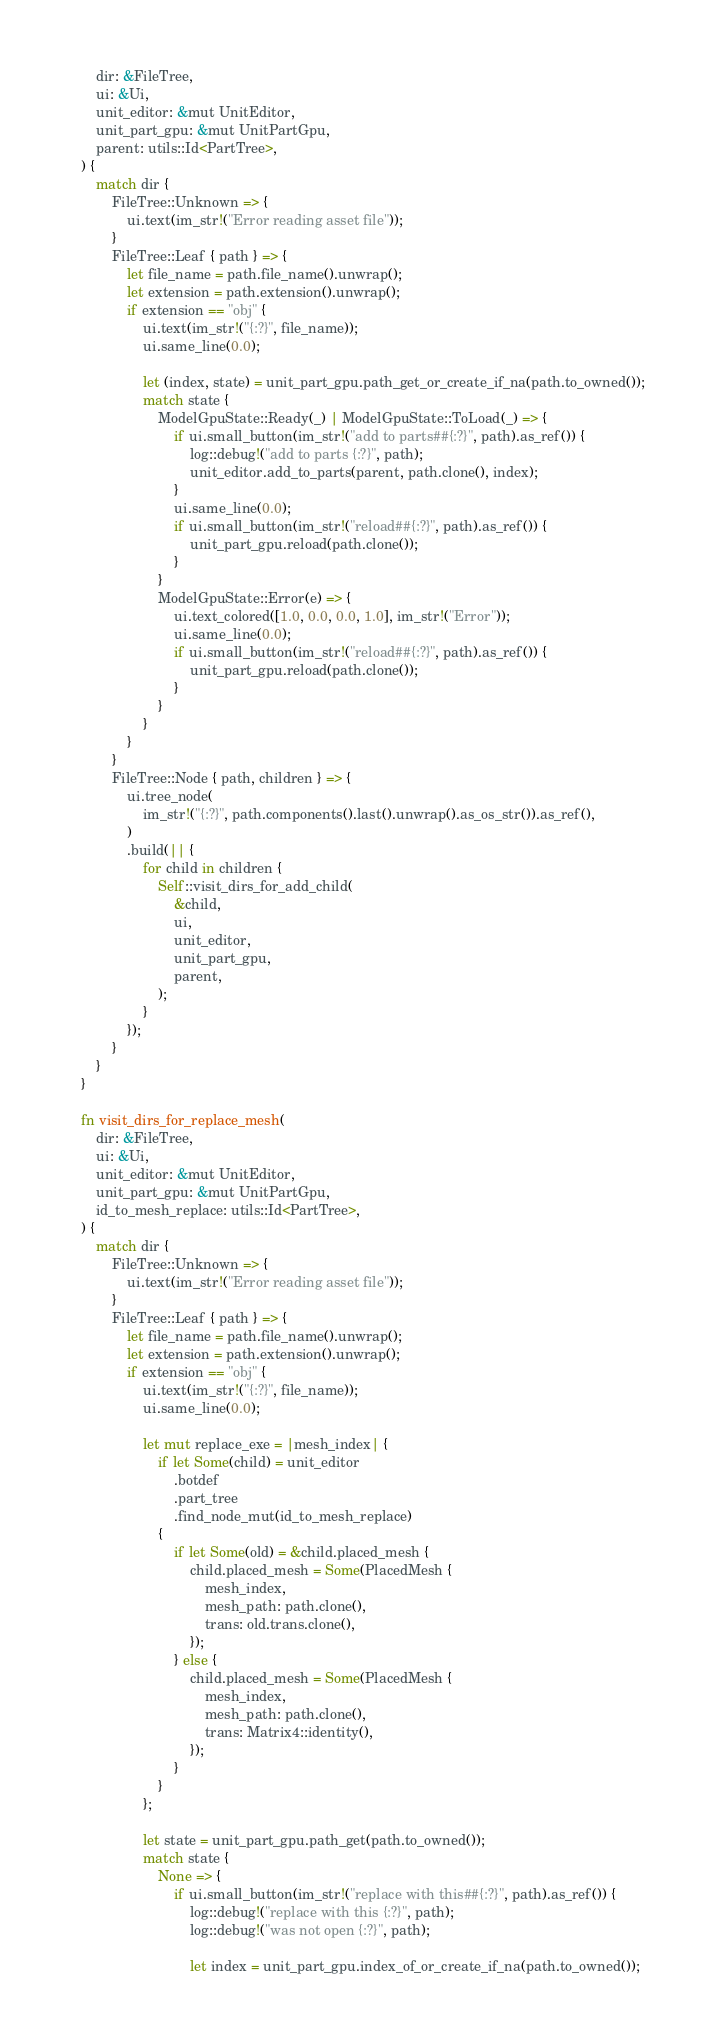<code> <loc_0><loc_0><loc_500><loc_500><_Rust_>        dir: &FileTree,
        ui: &Ui,
        unit_editor: &mut UnitEditor,
        unit_part_gpu: &mut UnitPartGpu,
        parent: utils::Id<PartTree>,
    ) {
        match dir {
            FileTree::Unknown => {
                ui.text(im_str!("Error reading asset file"));
            }
            FileTree::Leaf { path } => {
                let file_name = path.file_name().unwrap();
                let extension = path.extension().unwrap();
                if extension == "obj" {
                    ui.text(im_str!("{:?}", file_name));
                    ui.same_line(0.0);

                    let (index, state) = unit_part_gpu.path_get_or_create_if_na(path.to_owned());
                    match state {
                        ModelGpuState::Ready(_) | ModelGpuState::ToLoad(_) => {
                            if ui.small_button(im_str!("add to parts##{:?}", path).as_ref()) {
                                log::debug!("add to parts {:?}", path);
                                unit_editor.add_to_parts(parent, path.clone(), index);
                            }
                            ui.same_line(0.0);
                            if ui.small_button(im_str!("reload##{:?}", path).as_ref()) {
                                unit_part_gpu.reload(path.clone());
                            }
                        }
                        ModelGpuState::Error(e) => {
                            ui.text_colored([1.0, 0.0, 0.0, 1.0], im_str!("Error"));
                            ui.same_line(0.0);
                            if ui.small_button(im_str!("reload##{:?}", path).as_ref()) {
                                unit_part_gpu.reload(path.clone());
                            }
                        }
                    }
                }
            }
            FileTree::Node { path, children } => {
                ui.tree_node(
                    im_str!("{:?}", path.components().last().unwrap().as_os_str()).as_ref(),
                )
                .build(|| {
                    for child in children {
                        Self::visit_dirs_for_add_child(
                            &child,
                            ui,
                            unit_editor,
                            unit_part_gpu,
                            parent,
                        );
                    }
                });
            }
        }
    }

    fn visit_dirs_for_replace_mesh(
        dir: &FileTree,
        ui: &Ui,
        unit_editor: &mut UnitEditor,
        unit_part_gpu: &mut UnitPartGpu,
        id_to_mesh_replace: utils::Id<PartTree>,
    ) {
        match dir {
            FileTree::Unknown => {
                ui.text(im_str!("Error reading asset file"));
            }
            FileTree::Leaf { path } => {
                let file_name = path.file_name().unwrap();
                let extension = path.extension().unwrap();
                if extension == "obj" {
                    ui.text(im_str!("{:?}", file_name));
                    ui.same_line(0.0);

                    let mut replace_exe = |mesh_index| {
                        if let Some(child) = unit_editor
                            .botdef
                            .part_tree
                            .find_node_mut(id_to_mesh_replace)
                        {
                            if let Some(old) = &child.placed_mesh {
                                child.placed_mesh = Some(PlacedMesh {
                                    mesh_index,
                                    mesh_path: path.clone(),
                                    trans: old.trans.clone(),
                                });
                            } else {
                                child.placed_mesh = Some(PlacedMesh {
                                    mesh_index,
                                    mesh_path: path.clone(),
                                    trans: Matrix4::identity(),
                                });
                            }
                        }
                    };

                    let state = unit_part_gpu.path_get(path.to_owned());
                    match state {
                        None => {
                            if ui.small_button(im_str!("replace with this##{:?}", path).as_ref()) {
                                log::debug!("replace with this {:?}", path);
                                log::debug!("was not open {:?}", path);

                                let index = unit_part_gpu.index_of_or_create_if_na(path.to_owned());</code> 